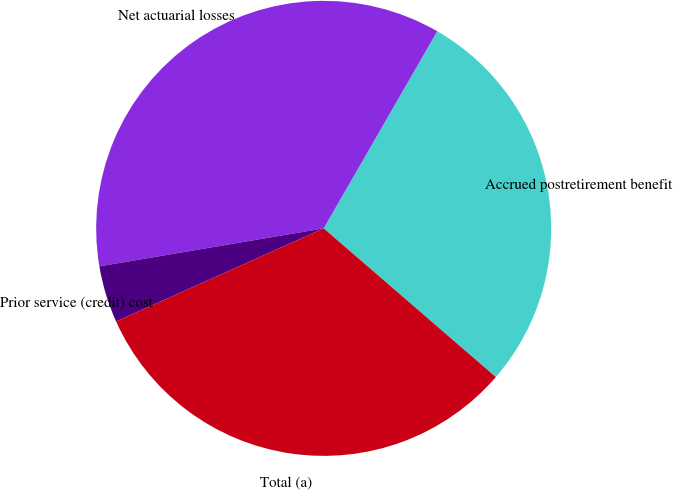Convert chart. <chart><loc_0><loc_0><loc_500><loc_500><pie_chart><fcel>Accrued postretirement benefit<fcel>Net actuarial losses<fcel>Prior service (credit) cost<fcel>Total (a)<nl><fcel>28.02%<fcel>35.99%<fcel>4.04%<fcel>31.95%<nl></chart> 